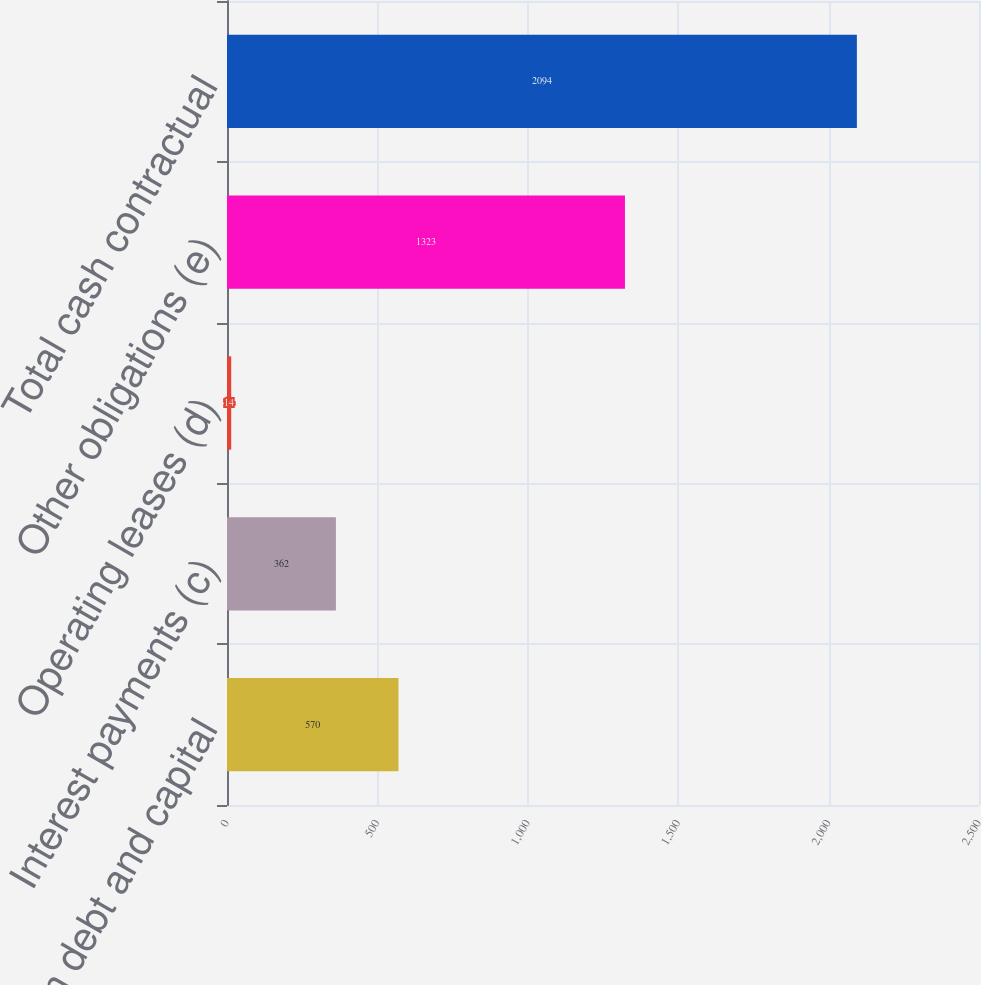Convert chart. <chart><loc_0><loc_0><loc_500><loc_500><bar_chart><fcel>Long-term debt and capital<fcel>Interest payments (c)<fcel>Operating leases (d)<fcel>Other obligations (e)<fcel>Total cash contractual<nl><fcel>570<fcel>362<fcel>14<fcel>1323<fcel>2094<nl></chart> 